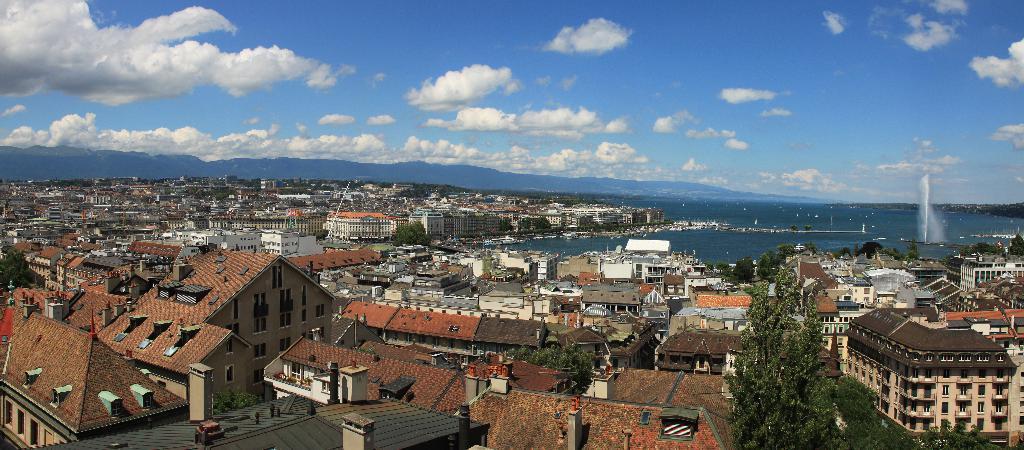Please provide a concise description of this image. This is the aerial view image of a city with buildings all over the place, in the back there is ocean with hills on the right side and above its sky with clouds. 